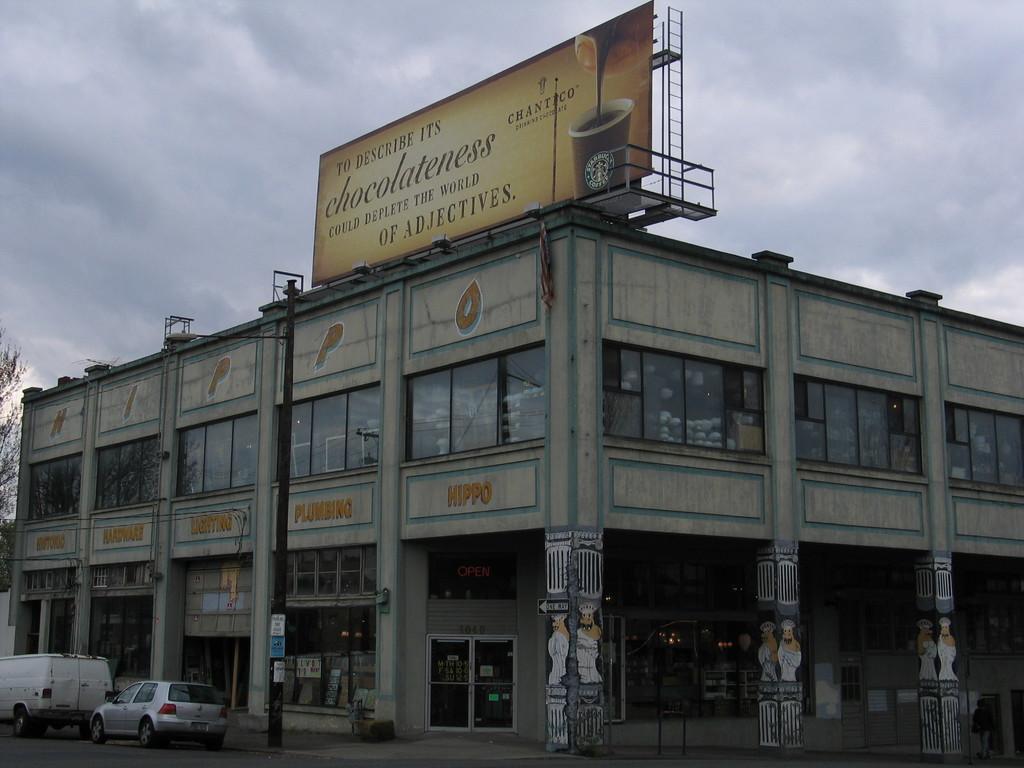Please provide a concise description of this image. In the image there is two stair building, it looks like a shopping complex and two vehicles are moving beside the building and there is an advertisement board kept upon the top of the building. 